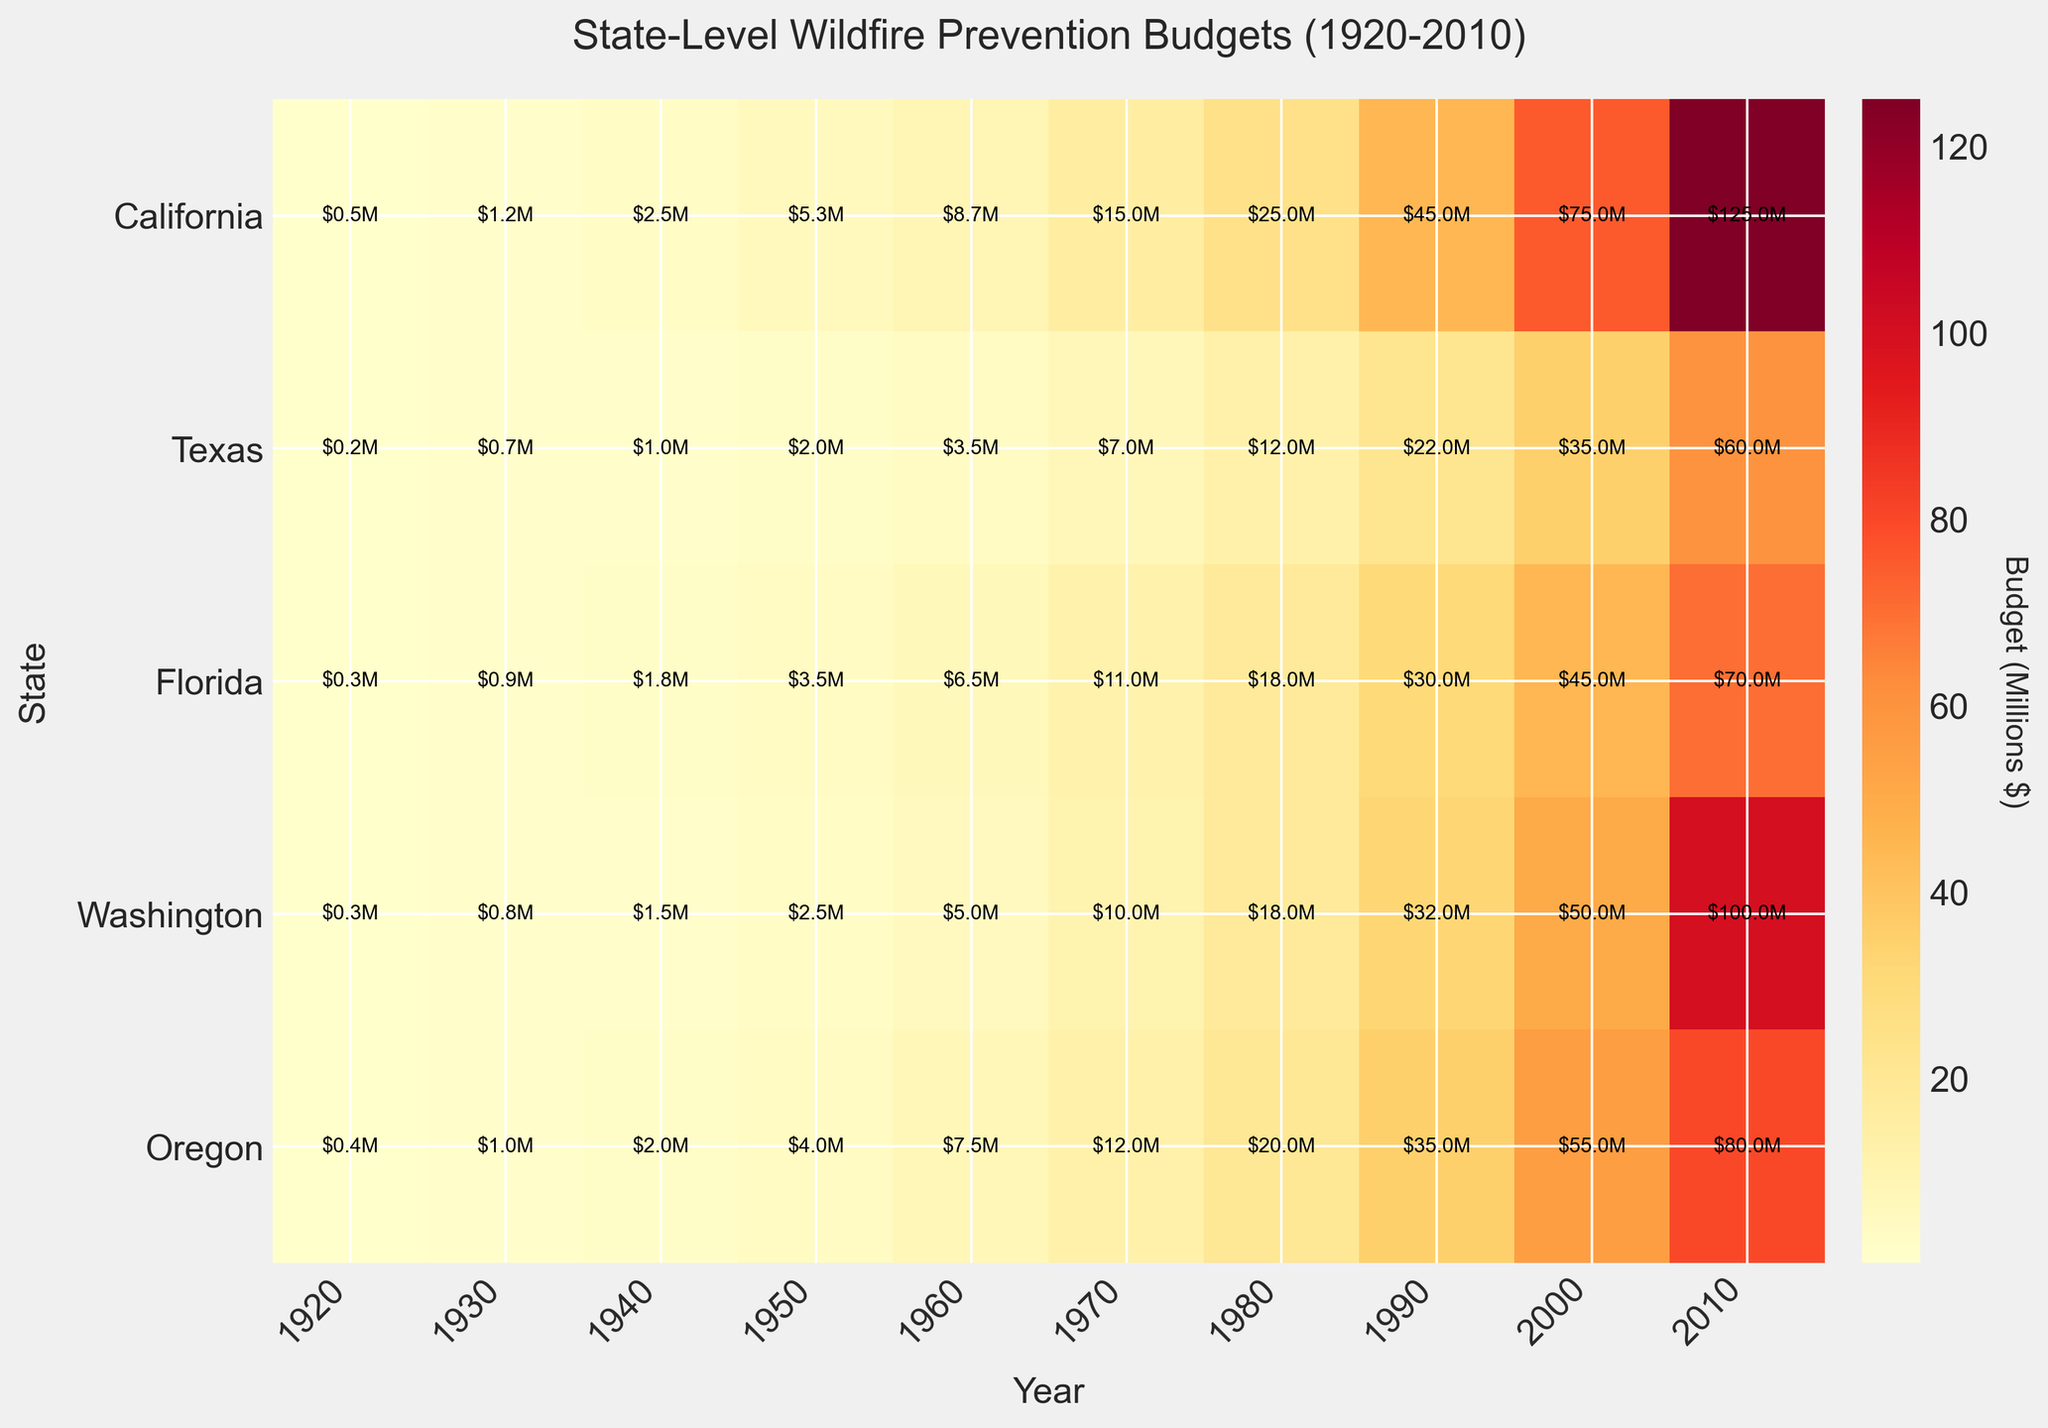What is the title of the figure? The title is typically located at the top of the figure. In this case, it reads "State-Level Wildfire Prevention Budgets (1920-2010)".
Answer: State-Level Wildfire Prevention Budgets (1920-2010) Which state has the highest budget in 2010? Locate the column for 2010 and identify the highest value in that column. The state corresponding to this value is California with a budget of $125.0 million.
Answer: California What is the general trend of California's wildfire prevention budget from 1920 to 2010? Examine the change in the color intensity for California’s row from 1920 to 2010. The colors shift from lighter shades to darker shades, indicating an increasing budget over the years.
Answer: Increasing In which decade did Texas's wildfire prevention budget first exceed $10 million? Identify the decade by looking for the first time Texas's budget surpasses $10 million. It occurs in 1970 when the budget is $10.0 million.
Answer: 1970 Compare the wildfire prevention budgets of Florida and Oregon in 1980. Which state had a higher budget and by how much? Find the budgets for both states in 1980: Florida has $12.0 million, and Oregon has $18.0 million. Calculate the difference: $18.0 million - $12.0 million = $6.0 million. Oregon had a higher budget by $6.0 million.
Answer: Oregon, $6.0 million Which state shows the smallest increase in wildfire prevention budget from 2000 to 2010? To find this, subtract the 2000 budget from the 2010 budget for each state and compare the differences. Texas increased from $50.0 million to $100.0 million, California from $75.0 million to $125.0 million, Florida from $35.0 million to $60.0 million, Washington from $55.0 million to $80.0 million, and Oregon from $45.0 million to $70.0 million. Florida has the smallest increase ($60.0 million - $35.0 million = $25.0 million).
Answer: Florida How many states had a wildfire prevention budget of at least $20 million in 1970? Identify the budgets for each state in 1970 and count how many are $20 million or more. Only California had a budget of at least $20 million in 1970 with $15.0 million.
Answer: 0 states What was the budget difference between California and Texas in 2000? Locate the budgets for both states in the year 2000: California has $75.0 million and Texas has $50.0 million. Calculate the difference: $75.0 million - $50.0 million = $25.0 million.
Answer: $25.0 million Which state's wildfire prevention budget has consistently been the lowest from 1920 to 2010? Compare the budget values over time for each state. By observing the color intensity (lighter shades indicating lower budgets) across all years, Florida consistently has lighter shades compared to other states.
Answer: Florida How did the budget for Washington change from 1950 to 1960? Find the budget values for Washington in 1950 ($4.0 million) and in 1960 ($7.5 million) and calculate the difference: $7.5 million - $4.0 million = $3.5 million. Washington's budget increased by $3.5 million.
Answer: Increased by $3.5 million 